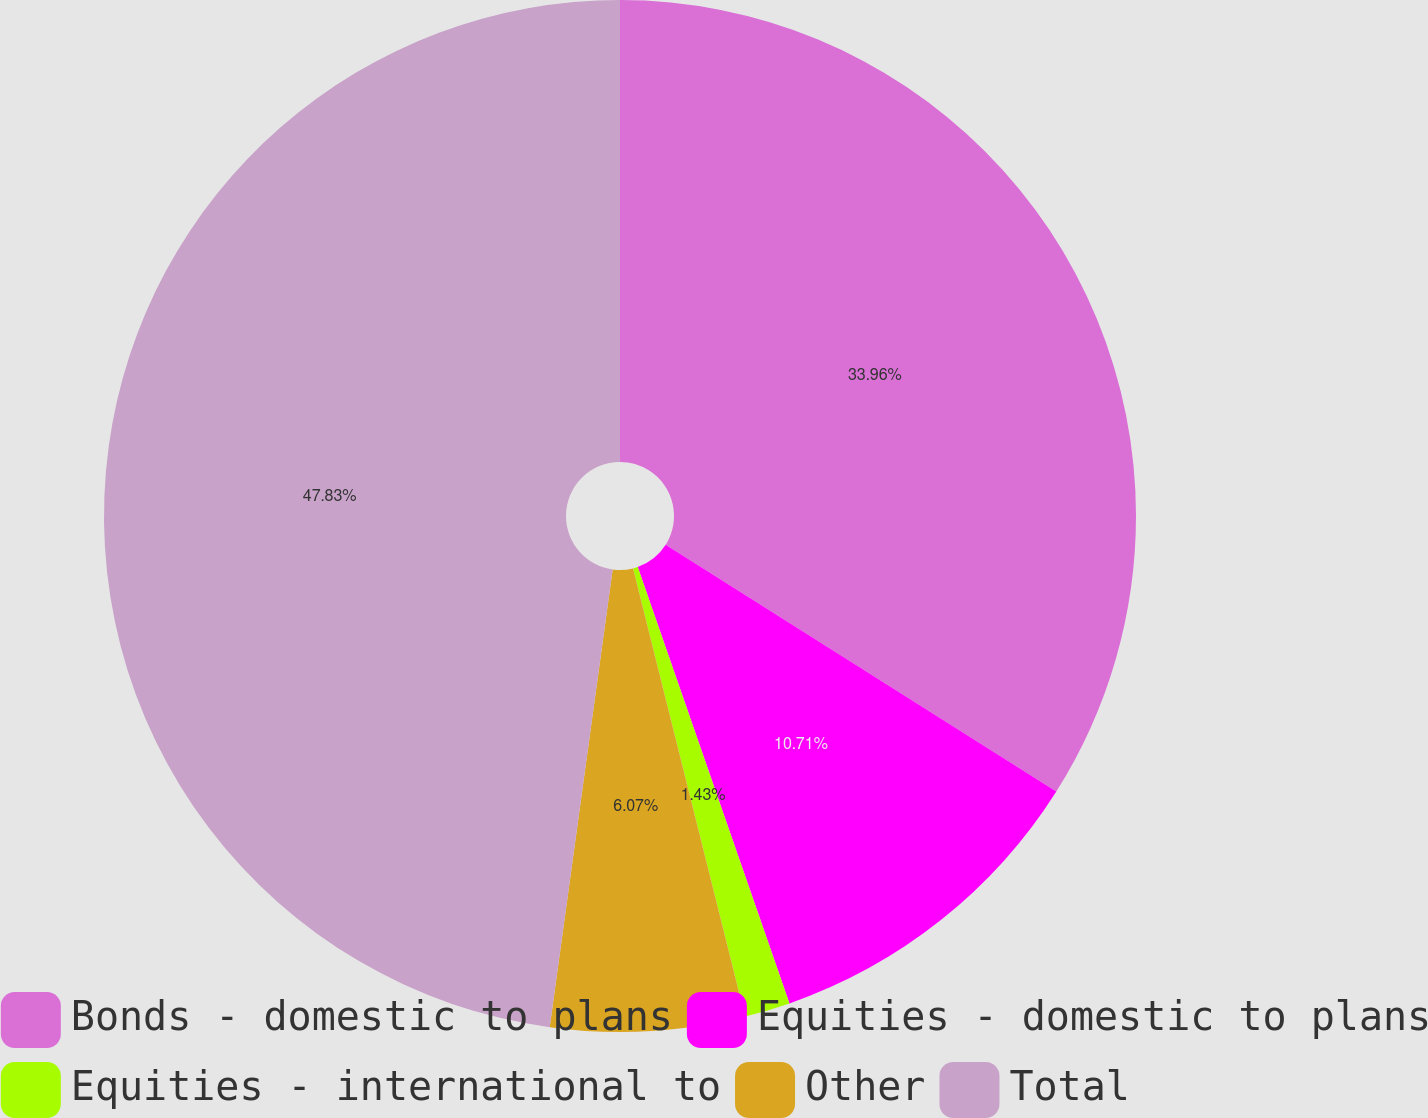<chart> <loc_0><loc_0><loc_500><loc_500><pie_chart><fcel>Bonds - domestic to plans<fcel>Equities - domestic to plans<fcel>Equities - international to<fcel>Other<fcel>Total<nl><fcel>33.96%<fcel>10.71%<fcel>1.43%<fcel>6.07%<fcel>47.82%<nl></chart> 